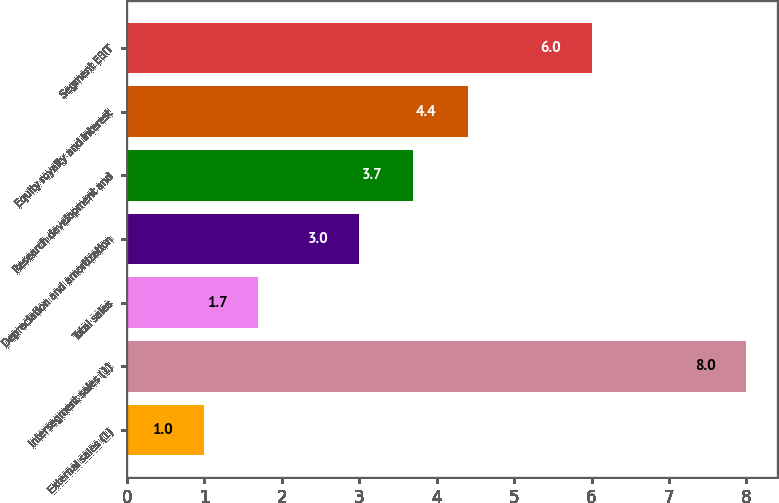Convert chart to OTSL. <chart><loc_0><loc_0><loc_500><loc_500><bar_chart><fcel>External sales (1)<fcel>Intersegment sales (1)<fcel>Total sales<fcel>Depreciation and amortization<fcel>Research development and<fcel>Equity royalty and interest<fcel>Segment EBIT<nl><fcel>1<fcel>8<fcel>1.7<fcel>3<fcel>3.7<fcel>4.4<fcel>6<nl></chart> 